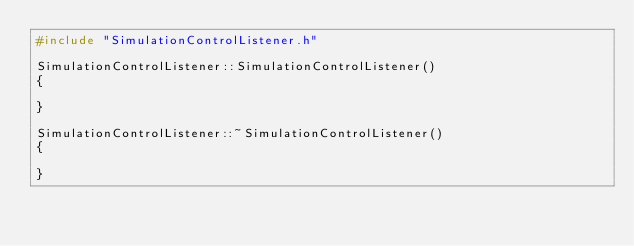<code> <loc_0><loc_0><loc_500><loc_500><_C++_>#include "SimulationControlListener.h"

SimulationControlListener::SimulationControlListener()
{

}

SimulationControlListener::~SimulationControlListener()
{

}
</code> 